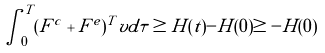<formula> <loc_0><loc_0><loc_500><loc_500>\int _ { 0 } ^ { T } ( F ^ { c } + F ^ { e } ) ^ { T } v d \tau \geq H ( t ) - H ( 0 ) \geq - H ( 0 )</formula> 